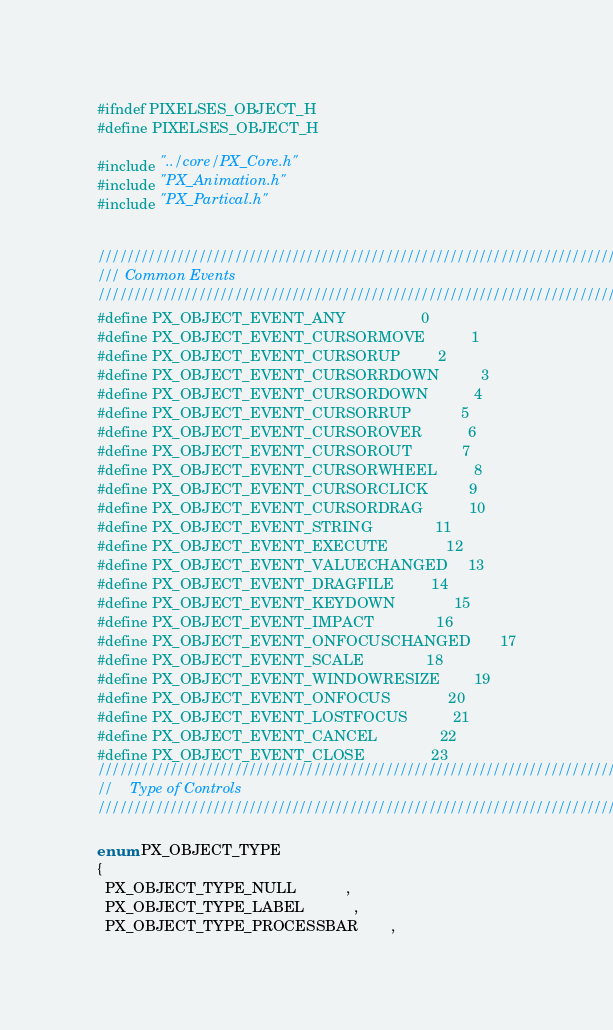<code> <loc_0><loc_0><loc_500><loc_500><_C_>#ifndef PIXELSES_OBJECT_H
#define PIXELSES_OBJECT_H

#include "../core/PX_Core.h"
#include "PX_Animation.h"
#include "PX_Partical.h"


//////////////////////////////////////////////////////////////////////////
/// Common Events
//////////////////////////////////////////////////////////////////////////
#define PX_OBJECT_EVENT_ANY					0
#define PX_OBJECT_EVENT_CURSORMOVE			1
#define PX_OBJECT_EVENT_CURSORUP			2
#define PX_OBJECT_EVENT_CURSORRDOWN			3
#define PX_OBJECT_EVENT_CURSORDOWN			4
#define PX_OBJECT_EVENT_CURSORRUP			5
#define PX_OBJECT_EVENT_CURSOROVER			6
#define PX_OBJECT_EVENT_CURSOROUT			7
#define PX_OBJECT_EVENT_CURSORWHEEL         8
#define PX_OBJECT_EVENT_CURSORCLICK			9
#define PX_OBJECT_EVENT_CURSORDRAG			10
#define PX_OBJECT_EVENT_STRING				11
#define PX_OBJECT_EVENT_EXECUTE				12
#define PX_OBJECT_EVENT_VALUECHANGED		13
#define PX_OBJECT_EVENT_DRAGFILE			14
#define PX_OBJECT_EVENT_KEYDOWN				15
#define PX_OBJECT_EVENT_IMPACT				16
#define PX_OBJECT_EVENT_ONFOCUSCHANGED		17
#define PX_OBJECT_EVENT_SCALE               18
#define PX_OBJECT_EVENT_WINDOWRESIZE        19
#define PX_OBJECT_EVENT_ONFOCUS				20
#define PX_OBJECT_EVENT_LOSTFOCUS           21
#define PX_OBJECT_EVENT_CANCEL				22
#define PX_OBJECT_EVENT_CLOSE				23
//////////////////////////////////////////////////////////////////////////////
//    Type of Controls
/////////////////////////////////////////////////////////////////////////////

enum PX_OBJECT_TYPE
{
  PX_OBJECT_TYPE_NULL			,
  PX_OBJECT_TYPE_LABEL			,
  PX_OBJECT_TYPE_PROCESSBAR		,</code> 